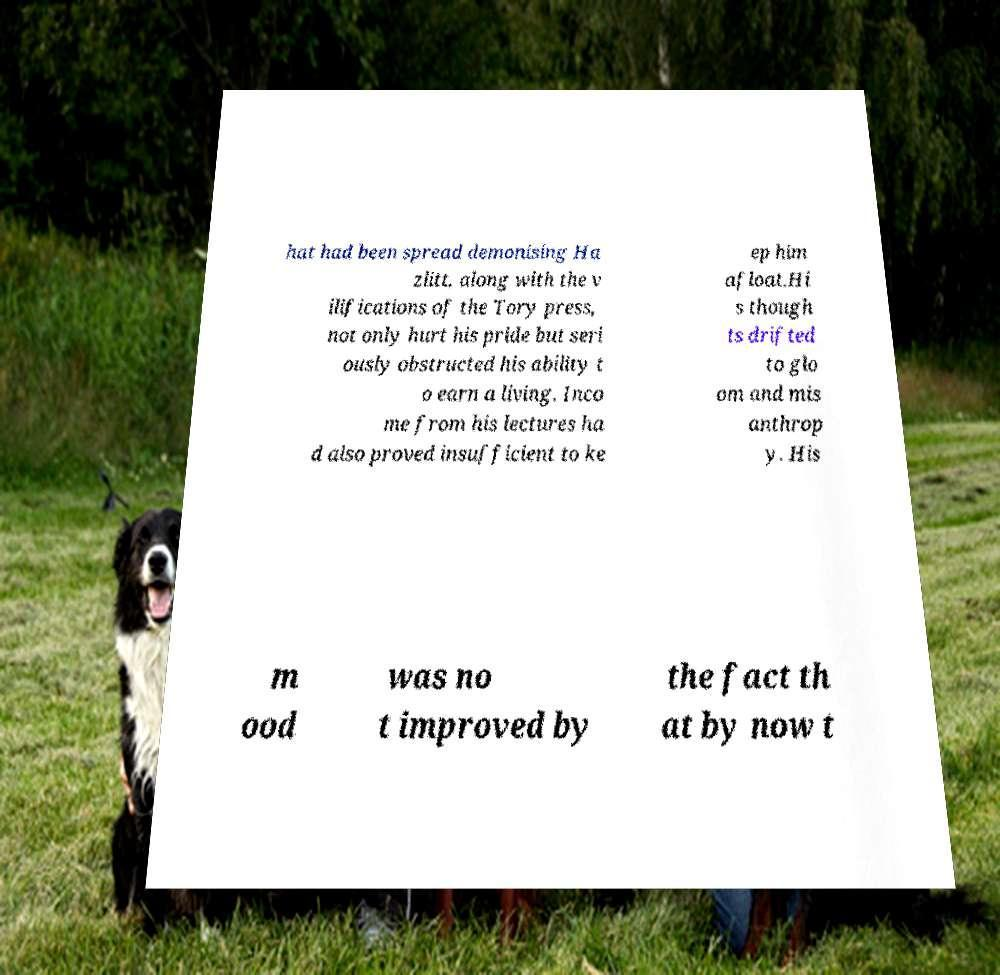Could you assist in decoding the text presented in this image and type it out clearly? hat had been spread demonising Ha zlitt, along with the v ilifications of the Tory press, not only hurt his pride but seri ously obstructed his ability t o earn a living. Inco me from his lectures ha d also proved insufficient to ke ep him afloat.Hi s though ts drifted to glo om and mis anthrop y. His m ood was no t improved by the fact th at by now t 